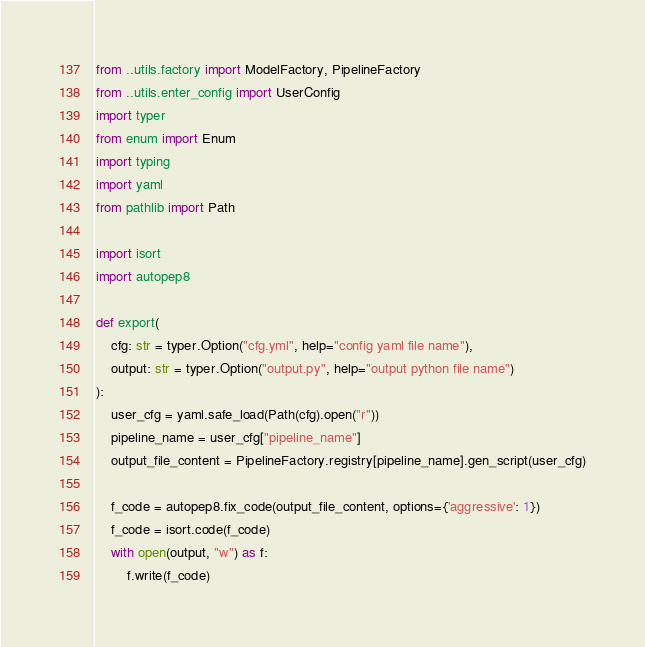<code> <loc_0><loc_0><loc_500><loc_500><_Python_>from ..utils.factory import ModelFactory, PipelineFactory
from ..utils.enter_config import UserConfig
import typer
from enum import Enum
import typing
import yaml
from pathlib import Path

import isort
import autopep8

def export(
    cfg: str = typer.Option("cfg.yml", help="config yaml file name"),
    output: str = typer.Option("output.py", help="output python file name")
):
    user_cfg = yaml.safe_load(Path(cfg).open("r"))
    pipeline_name = user_cfg["pipeline_name"]
    output_file_content = PipelineFactory.registry[pipeline_name].gen_script(user_cfg)

    f_code = autopep8.fix_code(output_file_content, options={'aggressive': 1})
    f_code = isort.code(f_code)
    with open(output, "w") as f:
        f.write(f_code)</code> 